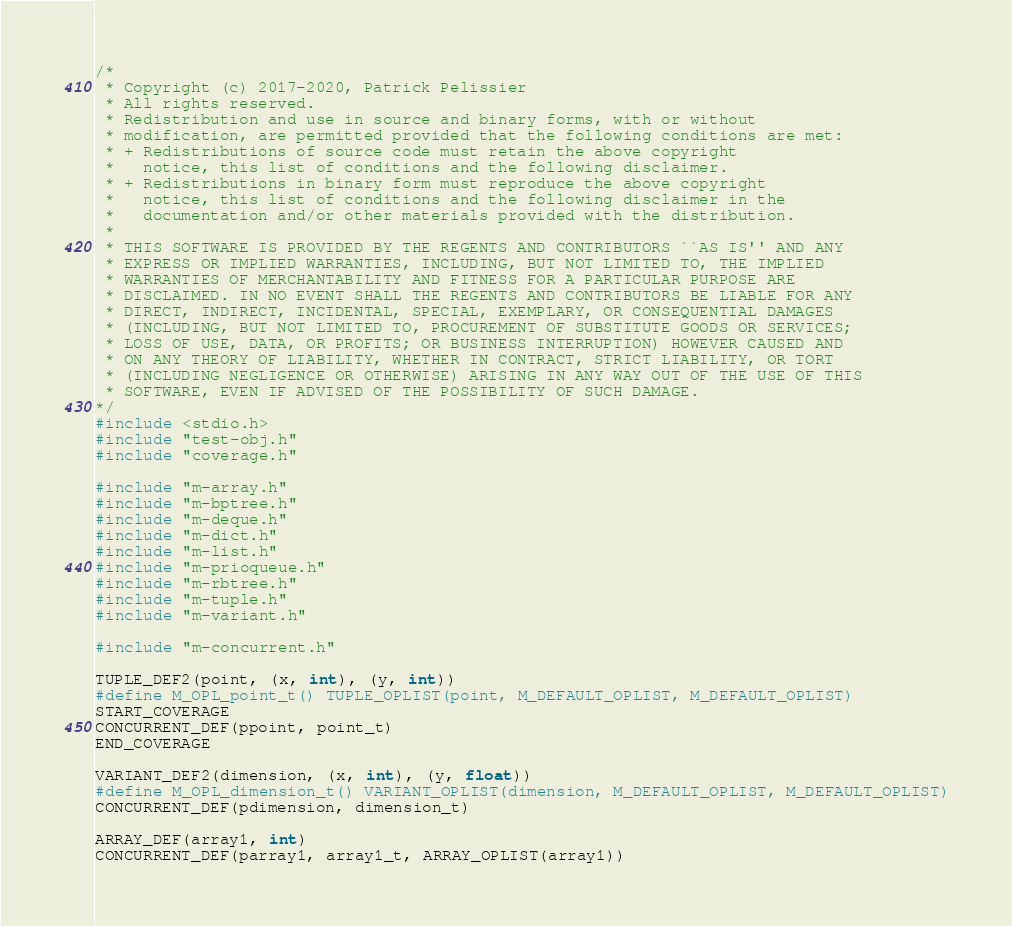Convert code to text. <code><loc_0><loc_0><loc_500><loc_500><_C_>/*
 * Copyright (c) 2017-2020, Patrick Pelissier
 * All rights reserved.
 * Redistribution and use in source and binary forms, with or without
 * modification, are permitted provided that the following conditions are met:
 * + Redistributions of source code must retain the above copyright
 *   notice, this list of conditions and the following disclaimer.
 * + Redistributions in binary form must reproduce the above copyright
 *   notice, this list of conditions and the following disclaimer in the
 *   documentation and/or other materials provided with the distribution.
 *
 * THIS SOFTWARE IS PROVIDED BY THE REGENTS AND CONTRIBUTORS ``AS IS'' AND ANY
 * EXPRESS OR IMPLIED WARRANTIES, INCLUDING, BUT NOT LIMITED TO, THE IMPLIED
 * WARRANTIES OF MERCHANTABILITY AND FITNESS FOR A PARTICULAR PURPOSE ARE
 * DISCLAIMED. IN NO EVENT SHALL THE REGENTS AND CONTRIBUTORS BE LIABLE FOR ANY
 * DIRECT, INDIRECT, INCIDENTAL, SPECIAL, EXEMPLARY, OR CONSEQUENTIAL DAMAGES
 * (INCLUDING, BUT NOT LIMITED TO, PROCUREMENT OF SUBSTITUTE GOODS OR SERVICES;
 * LOSS OF USE, DATA, OR PROFITS; OR BUSINESS INTERRUPTION) HOWEVER CAUSED AND
 * ON ANY THEORY OF LIABILITY, WHETHER IN CONTRACT, STRICT LIABILITY, OR TORT
 * (INCLUDING NEGLIGENCE OR OTHERWISE) ARISING IN ANY WAY OUT OF THE USE OF THIS
 * SOFTWARE, EVEN IF ADVISED OF THE POSSIBILITY OF SUCH DAMAGE.
*/
#include <stdio.h>
#include "test-obj.h"
#include "coverage.h"

#include "m-array.h"
#include "m-bptree.h"
#include "m-deque.h"
#include "m-dict.h"
#include "m-list.h"
#include "m-prioqueue.h"
#include "m-rbtree.h"
#include "m-tuple.h"
#include "m-variant.h"

#include "m-concurrent.h"

TUPLE_DEF2(point, (x, int), (y, int))
#define M_OPL_point_t() TUPLE_OPLIST(point, M_DEFAULT_OPLIST, M_DEFAULT_OPLIST)
START_COVERAGE
CONCURRENT_DEF(ppoint, point_t)
END_COVERAGE

VARIANT_DEF2(dimension, (x, int), (y, float))
#define M_OPL_dimension_t() VARIANT_OPLIST(dimension, M_DEFAULT_OPLIST, M_DEFAULT_OPLIST)
CONCURRENT_DEF(pdimension, dimension_t)

ARRAY_DEF(array1, int)
CONCURRENT_DEF(parray1, array1_t, ARRAY_OPLIST(array1))
</code> 